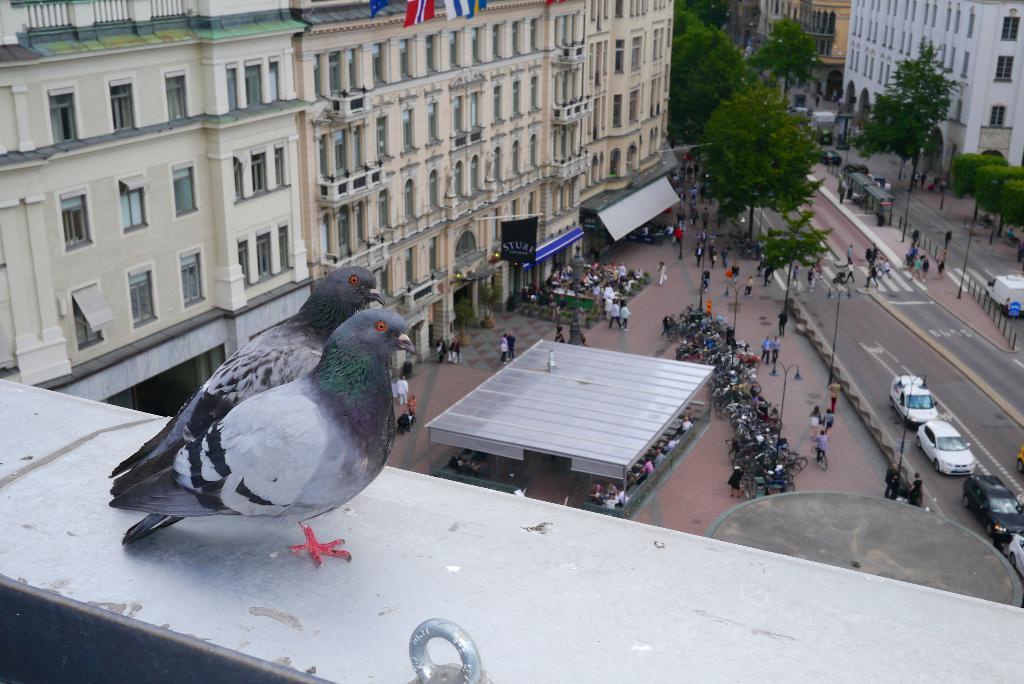Can you describe this image briefly? This image is taken from the top. In this image there are two pigeons standing on the floor at the top. At the bottom there are so many cycles which are parked on the floor. On the right side there is a road on which there are vehicles and some people are crossing the zebra crossing Beside the road there are trees on either side of the road. On the left side there are buildings. At the bottom there are so many people who are walking on the floor. 